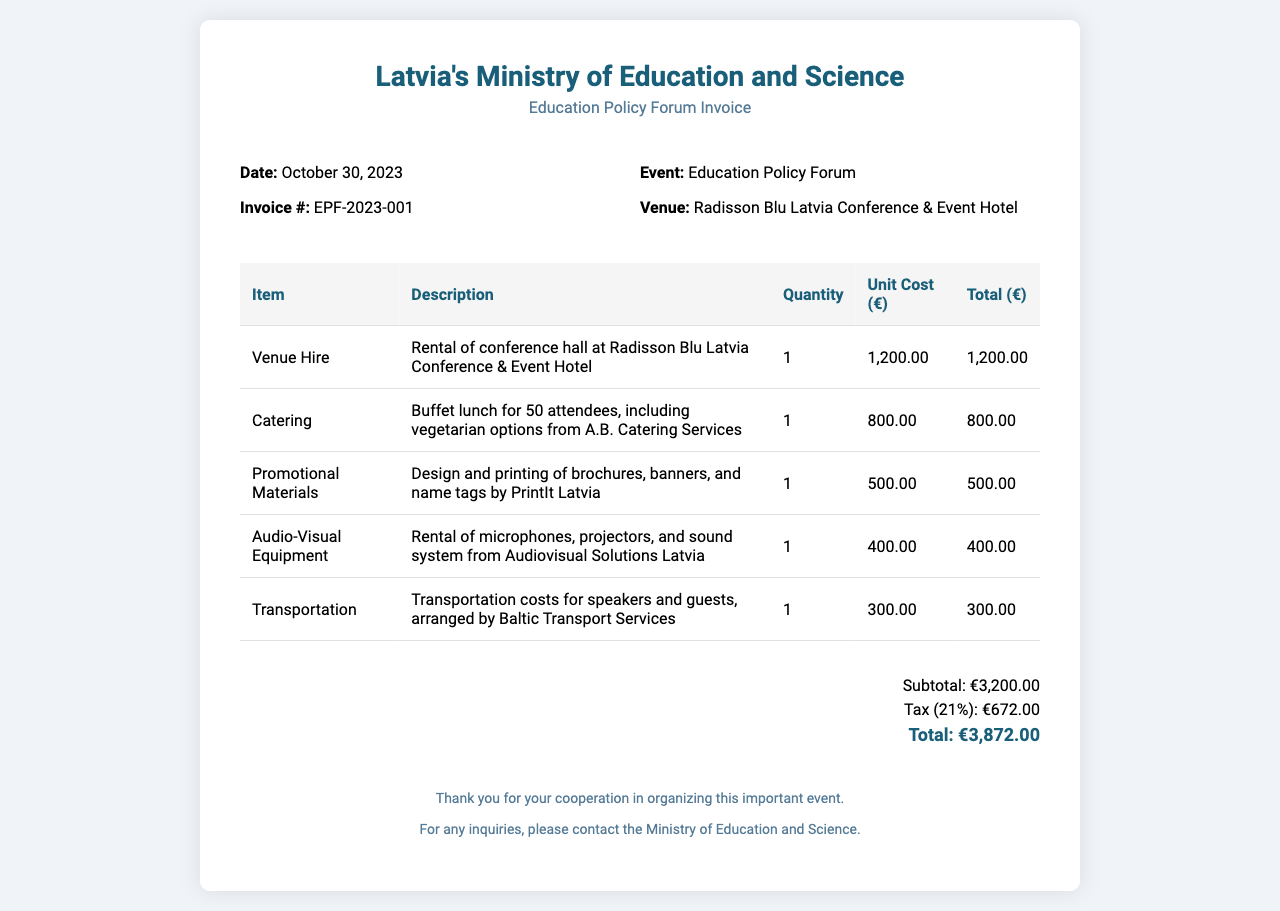What is the date of the invoice? The date of the invoice is mentioned in the document, which states October 30, 2023.
Answer: October 30, 2023 What is the total amount due? The total amount due is provided in the total section of the document as €3,872.00.
Answer: €3,872.00 What is the unit cost of venue hire? The unit cost for venue hire is specified in the table, where it is listed as €1,200.00.
Answer: €1,200.00 Who provided the catering services? The catering services are indicated to be from A.B. Catering Services in the description of the catering item.
Answer: A.B. Catering Services What is the tax percentage applied in this invoice? The tax percentage is stated in the document, which shows it as 21%.
Answer: 21% Which venue hosted the Education Policy Forum? The venue where the forum was held is mentioned in the invoice as Radisson Blu Latvia Conference & Event Hotel.
Answer: Radisson Blu Latvia Conference & Event Hotel What is included in the promotional materials? The description indicates that brochures, banners, and name tags were included, designed and printed by PrintIt Latvia.
Answer: Brochures, banners, and name tags How many attendees were catered for? The number of attendees mentioned for the catering service is 50.
Answer: 50 What is the subtotal before tax? The subtotal is clearly listed in the total section, marked as €3,200.00.
Answer: €3,200.00 